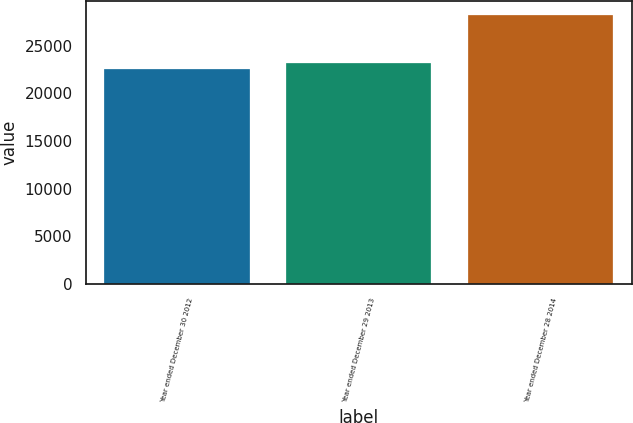Convert chart. <chart><loc_0><loc_0><loc_500><loc_500><bar_chart><fcel>Year ended December 30 2012<fcel>Year ended December 29 2013<fcel>Year ended December 28 2014<nl><fcel>22576<fcel>23144<fcel>28256<nl></chart> 